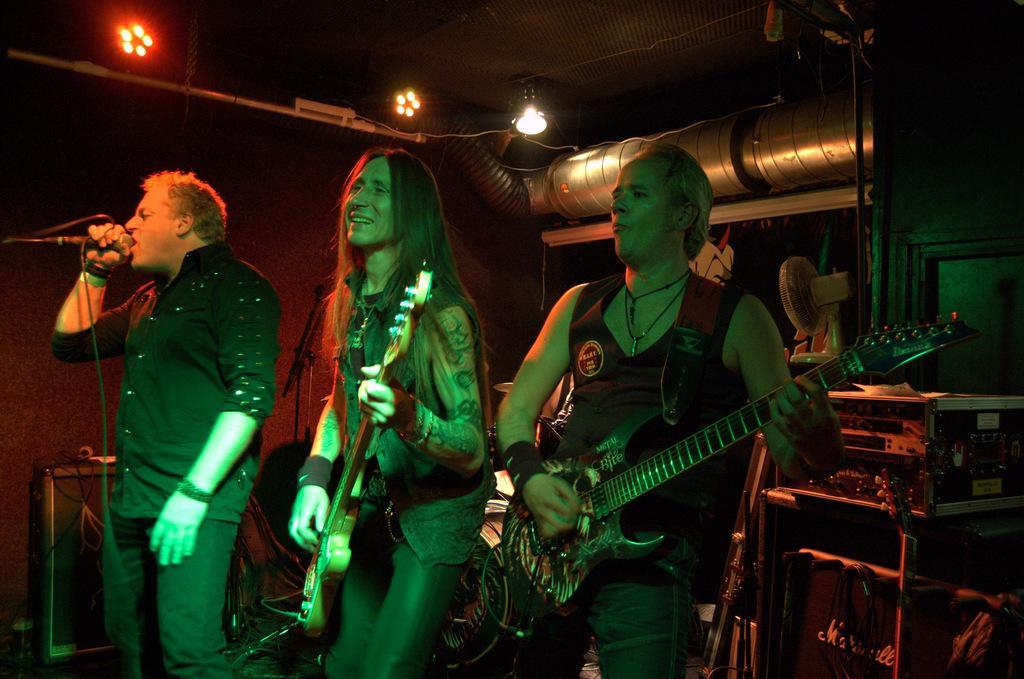Could you give a brief overview of what you see in this image? In this image, 3 peoples are standing. Two are holding a musical instrument. On the left side, the human is holding a microphone. He is singing in-front of microphone. At the background, we can see some instruments, wires, table fan, iron things, lights. Roof we can see. Here we can see pipe. The background, we can see another musical instrument. Here we can see human hand. 